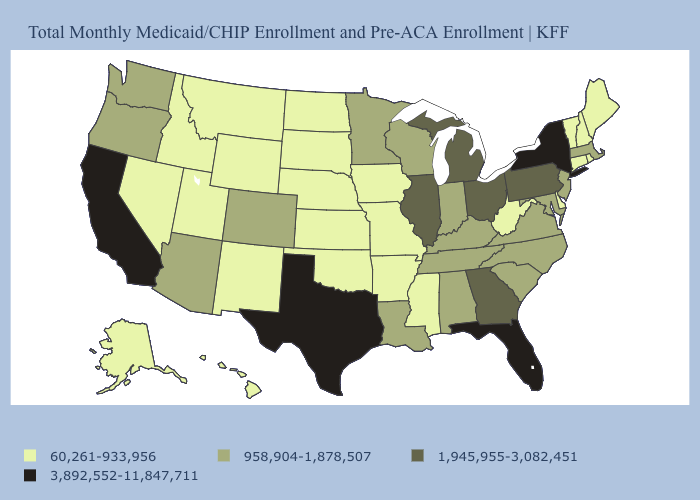What is the lowest value in the South?
Keep it brief. 60,261-933,956. Does New Hampshire have the same value as Oklahoma?
Concise answer only. Yes. Which states hav the highest value in the West?
Quick response, please. California. What is the value of Washington?
Give a very brief answer. 958,904-1,878,507. Among the states that border Kansas , does Missouri have the highest value?
Give a very brief answer. No. Does Mississippi have the lowest value in the South?
Answer briefly. Yes. What is the highest value in the South ?
Keep it brief. 3,892,552-11,847,711. Name the states that have a value in the range 958,904-1,878,507?
Short answer required. Alabama, Arizona, Colorado, Indiana, Kentucky, Louisiana, Maryland, Massachusetts, Minnesota, New Jersey, North Carolina, Oregon, South Carolina, Tennessee, Virginia, Washington, Wisconsin. Does Pennsylvania have the lowest value in the USA?
Short answer required. No. Which states have the highest value in the USA?
Answer briefly. California, Florida, New York, Texas. Does the first symbol in the legend represent the smallest category?
Short answer required. Yes. Among the states that border South Dakota , does Minnesota have the highest value?
Give a very brief answer. Yes. What is the value of Kentucky?
Give a very brief answer. 958,904-1,878,507. Name the states that have a value in the range 3,892,552-11,847,711?
Concise answer only. California, Florida, New York, Texas. Among the states that border New Mexico , which have the highest value?
Be succinct. Texas. 